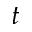<formula> <loc_0><loc_0><loc_500><loc_500>t</formula> 